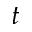<formula> <loc_0><loc_0><loc_500><loc_500>t</formula> 